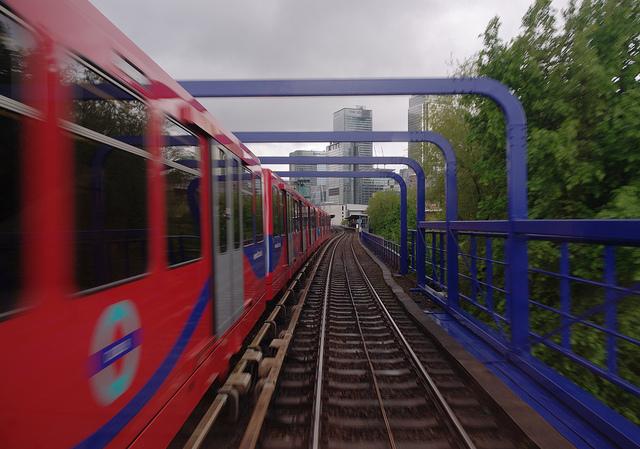How many red train cars are in this image?
Quick response, please. 5. How many elbows are hanging out the windows?
Give a very brief answer. 0. Are the windows on the train closed?
Give a very brief answer. Yes. Is the train moving?
Quick response, please. Yes. How many rectangles in each section of railing?
Quick response, please. 9. 